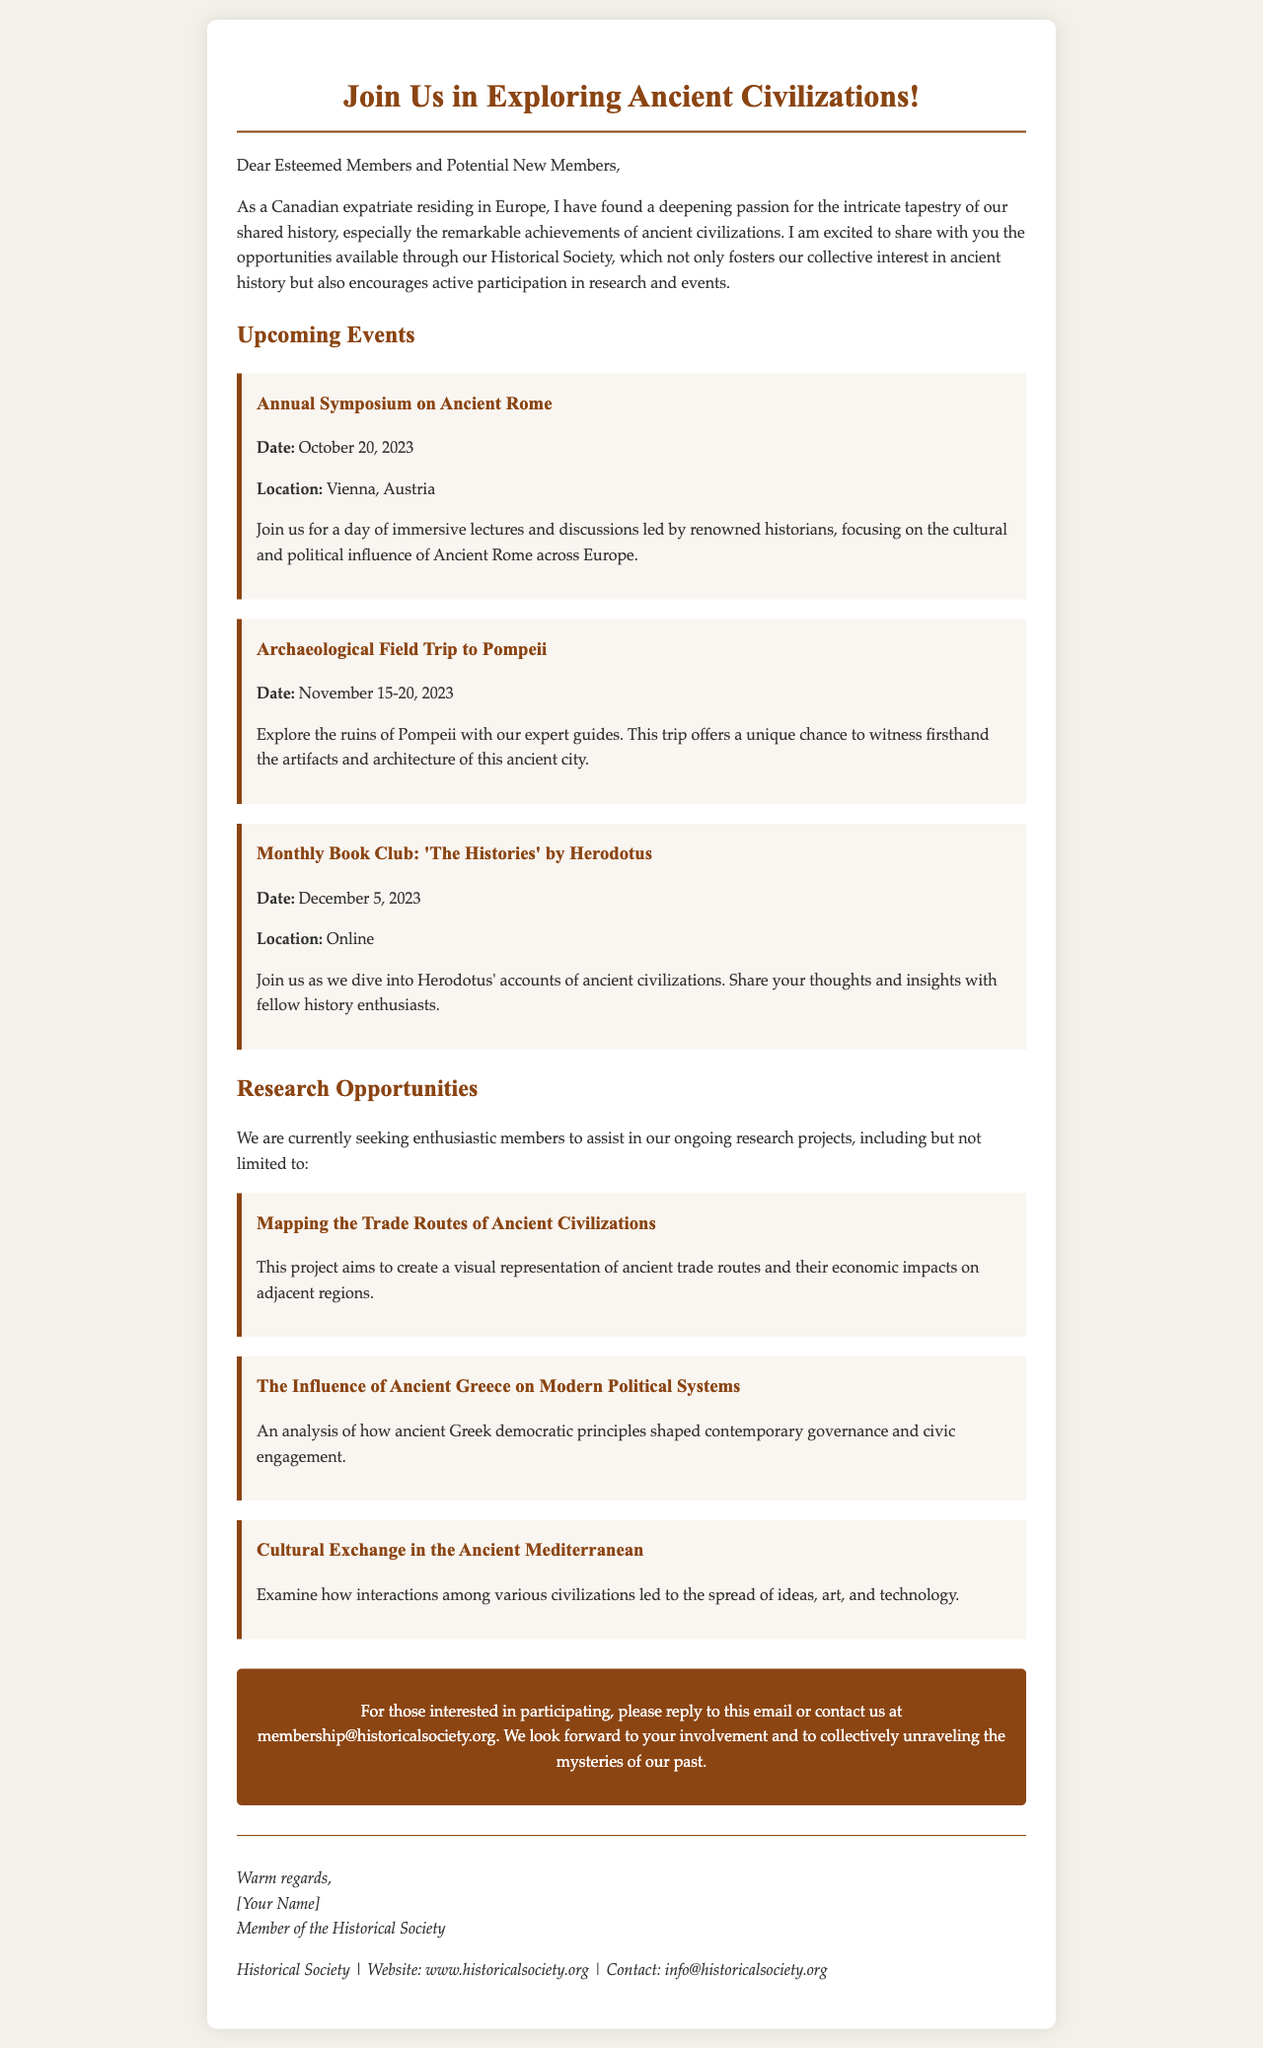What is the date of the Annual Symposium on Ancient Rome? The date is specifically mentioned in the events section as October 20, 2023.
Answer: October 20, 2023 Where is the Archaeological Field Trip to Pompeii taking place? The location is indicated in the details of the event as Pompeii.
Answer: Pompeii What is the title of the book for the Monthly Book Club? The title of the book is summarized in the event details as 'The Histories' by Herodotus.
Answer: 'The Histories' by Herodotus How many research projects are currently mentioned? The document lists three ongoing research projects under Research Opportunities.
Answer: Three What is the primary focus of the project on ancient trade routes? The project aims to create a visual representation, as described in the research project details.
Answer: Visual representation Who should interested participants contact for more information? The contact information is stated at the end of the document, which is membership@historicalsociety.org.
Answer: membership@historicalsociety.org What is highlighted as a significant theme in the monthly book club event? The theme of the book club revolves around the accounts of ancient civilizations.
Answer: Ancient civilizations What kind of interaction does the research project on Cultural Exchange in the Ancient Mediterranean analyze? It examines interactions among various civilizations, as explained in the project description.
Answer: Interactions among various civilizations 